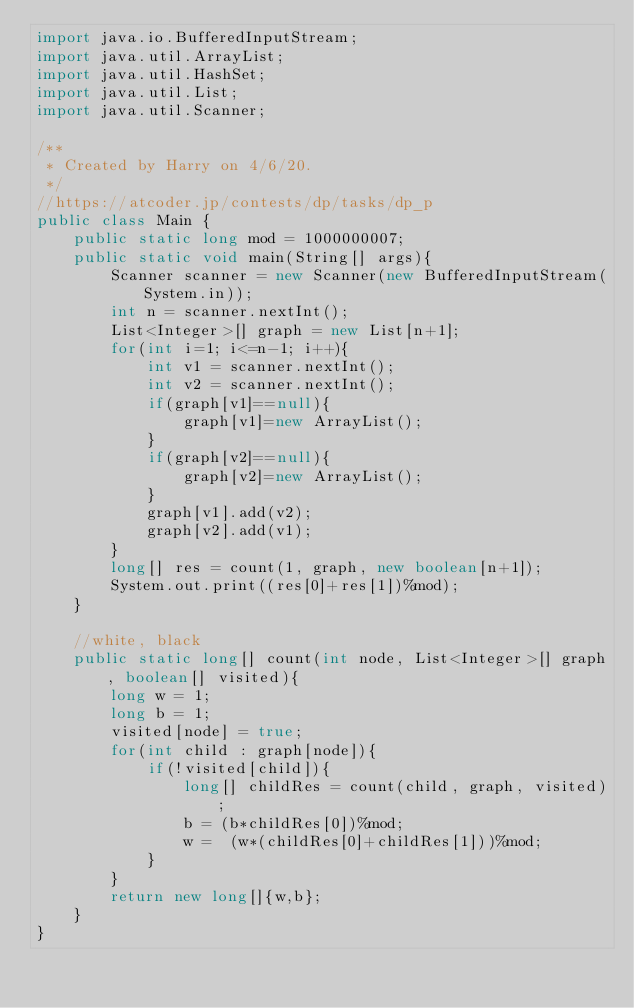Convert code to text. <code><loc_0><loc_0><loc_500><loc_500><_Java_>import java.io.BufferedInputStream;
import java.util.ArrayList;
import java.util.HashSet;
import java.util.List;
import java.util.Scanner;

/**
 * Created by Harry on 4/6/20.
 */
//https://atcoder.jp/contests/dp/tasks/dp_p
public class Main {
    public static long mod = 1000000007;
    public static void main(String[] args){
        Scanner scanner = new Scanner(new BufferedInputStream(System.in));
        int n = scanner.nextInt();
        List<Integer>[] graph = new List[n+1];
        for(int i=1; i<=n-1; i++){
            int v1 = scanner.nextInt();
            int v2 = scanner.nextInt();
            if(graph[v1]==null){
                graph[v1]=new ArrayList();
            }
            if(graph[v2]==null){
                graph[v2]=new ArrayList();
            }
            graph[v1].add(v2);
            graph[v2].add(v1);
        }
        long[] res = count(1, graph, new boolean[n+1]);
        System.out.print((res[0]+res[1])%mod);
    }

    //white, black
    public static long[] count(int node, List<Integer>[] graph, boolean[] visited){
        long w = 1;
        long b = 1;
        visited[node] = true;
        for(int child : graph[node]){
            if(!visited[child]){
                long[] childRes = count(child, graph, visited);
                b = (b*childRes[0])%mod;
                w =  (w*(childRes[0]+childRes[1]))%mod;
            }
        }
        return new long[]{w,b};
    }
}
</code> 